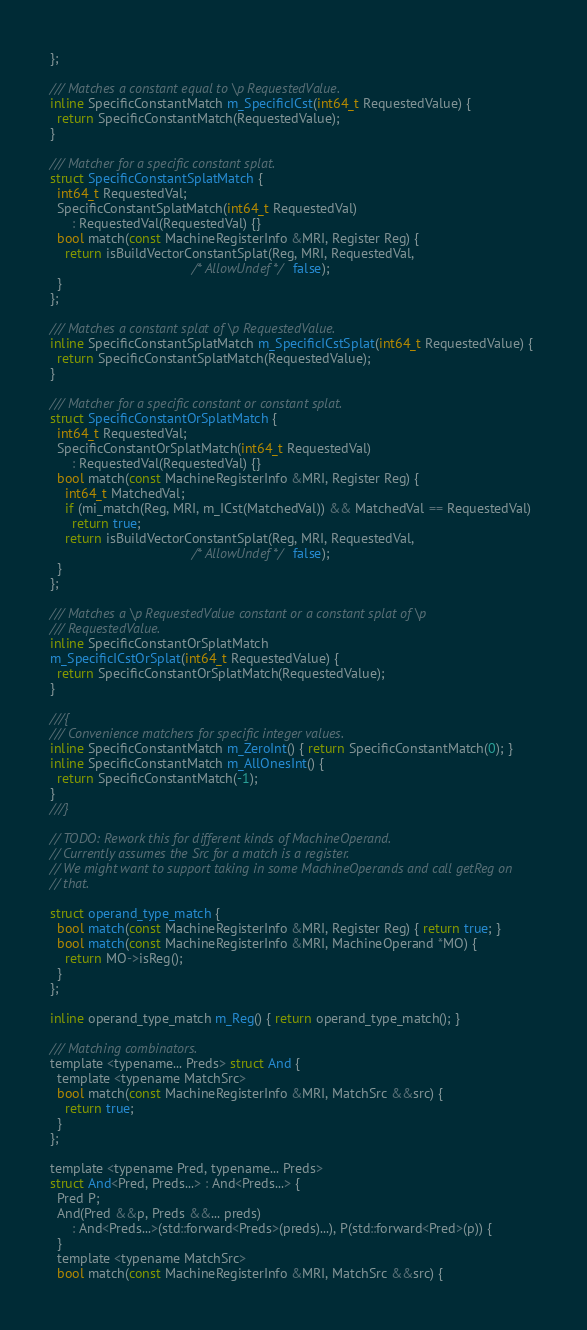Convert code to text. <code><loc_0><loc_0><loc_500><loc_500><_C_>};

/// Matches a constant equal to \p RequestedValue.
inline SpecificConstantMatch m_SpecificICst(int64_t RequestedValue) {
  return SpecificConstantMatch(RequestedValue);
}

/// Matcher for a specific constant splat.
struct SpecificConstantSplatMatch {
  int64_t RequestedVal;
  SpecificConstantSplatMatch(int64_t RequestedVal)
      : RequestedVal(RequestedVal) {}
  bool match(const MachineRegisterInfo &MRI, Register Reg) {
    return isBuildVectorConstantSplat(Reg, MRI, RequestedVal,
                                      /* AllowUndef */ false);
  }
};

/// Matches a constant splat of \p RequestedValue.
inline SpecificConstantSplatMatch m_SpecificICstSplat(int64_t RequestedValue) {
  return SpecificConstantSplatMatch(RequestedValue);
}

/// Matcher for a specific constant or constant splat.
struct SpecificConstantOrSplatMatch {
  int64_t RequestedVal;
  SpecificConstantOrSplatMatch(int64_t RequestedVal)
      : RequestedVal(RequestedVal) {}
  bool match(const MachineRegisterInfo &MRI, Register Reg) {
    int64_t MatchedVal;
    if (mi_match(Reg, MRI, m_ICst(MatchedVal)) && MatchedVal == RequestedVal)
      return true;
    return isBuildVectorConstantSplat(Reg, MRI, RequestedVal,
                                      /* AllowUndef */ false);
  }
};

/// Matches a \p RequestedValue constant or a constant splat of \p
/// RequestedValue.
inline SpecificConstantOrSplatMatch
m_SpecificICstOrSplat(int64_t RequestedValue) {
  return SpecificConstantOrSplatMatch(RequestedValue);
}

///{
/// Convenience matchers for specific integer values.
inline SpecificConstantMatch m_ZeroInt() { return SpecificConstantMatch(0); }
inline SpecificConstantMatch m_AllOnesInt() {
  return SpecificConstantMatch(-1);
}
///}

// TODO: Rework this for different kinds of MachineOperand.
// Currently assumes the Src for a match is a register.
// We might want to support taking in some MachineOperands and call getReg on
// that.

struct operand_type_match {
  bool match(const MachineRegisterInfo &MRI, Register Reg) { return true; }
  bool match(const MachineRegisterInfo &MRI, MachineOperand *MO) {
    return MO->isReg();
  }
};

inline operand_type_match m_Reg() { return operand_type_match(); }

/// Matching combinators.
template <typename... Preds> struct And {
  template <typename MatchSrc>
  bool match(const MachineRegisterInfo &MRI, MatchSrc &&src) {
    return true;
  }
};

template <typename Pred, typename... Preds>
struct And<Pred, Preds...> : And<Preds...> {
  Pred P;
  And(Pred &&p, Preds &&... preds)
      : And<Preds...>(std::forward<Preds>(preds)...), P(std::forward<Pred>(p)) {
  }
  template <typename MatchSrc>
  bool match(const MachineRegisterInfo &MRI, MatchSrc &&src) {</code> 